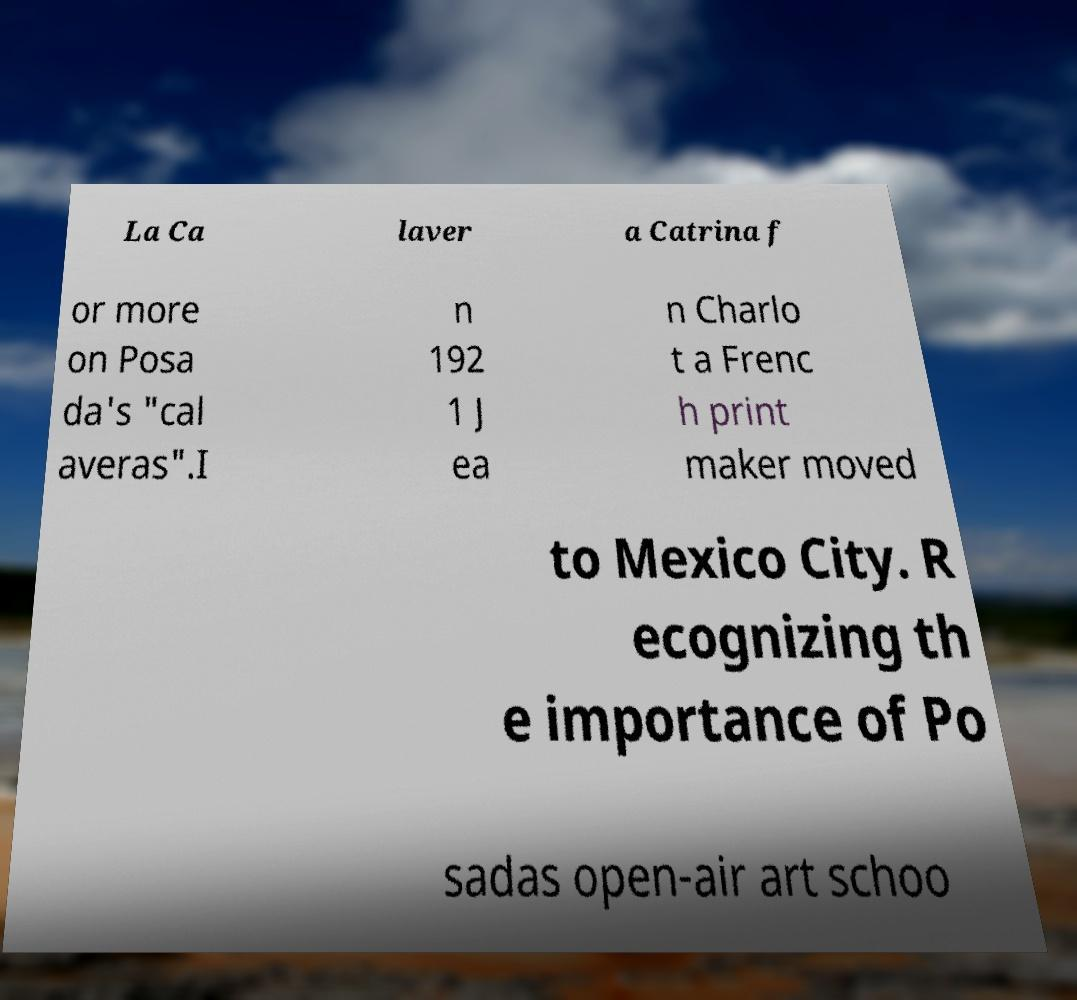Can you read and provide the text displayed in the image?This photo seems to have some interesting text. Can you extract and type it out for me? La Ca laver a Catrina f or more on Posa da's "cal averas".I n 192 1 J ea n Charlo t a Frenc h print maker moved to Mexico City. R ecognizing th e importance of Po sadas open-air art schoo 